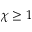<formula> <loc_0><loc_0><loc_500><loc_500>\chi \geq 1</formula> 